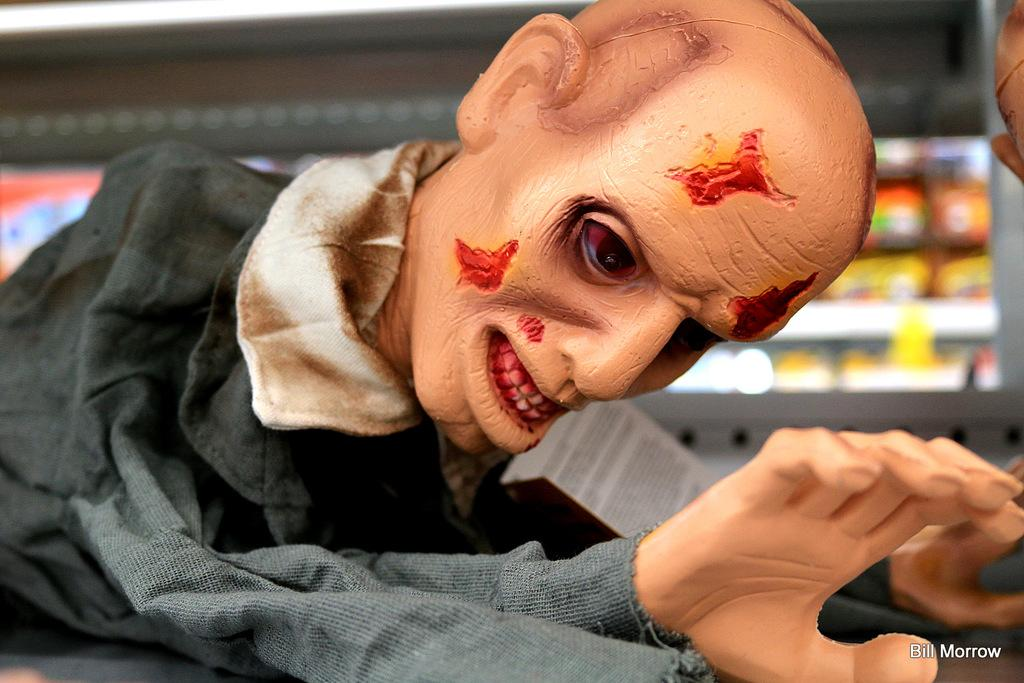What is the main subject of the image? There is a sculpture of a person in the image. Can you describe the background of the image? The background of the image is blurred. Is there any additional information or markings on the image? Yes, there is a watermark on the bottom right side of the image. What type of crime is being committed in the image? There is no crime being committed in the image; it features a sculpture of a person with a blurred background and a watermark. How many pins are visible in the image? There are no pins present in the image. 